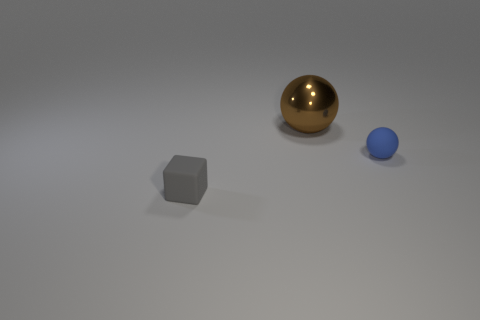Subtract all balls. How many objects are left? 1 Add 2 tiny green balls. How many objects exist? 5 Add 1 metal spheres. How many metal spheres are left? 2 Add 1 spheres. How many spheres exist? 3 Subtract 1 brown spheres. How many objects are left? 2 Subtract all brown objects. Subtract all small spheres. How many objects are left? 1 